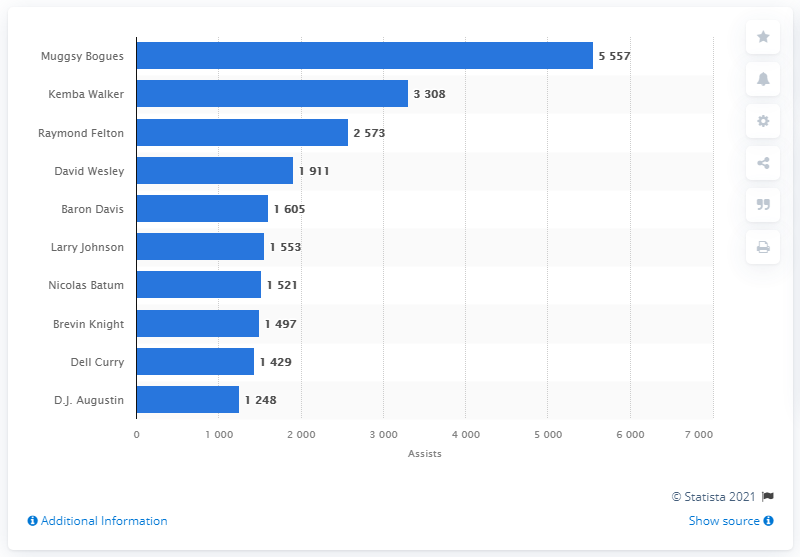Identify some key points in this picture. The current leader in career assists for the Charlotte Hornets is Muggsy Bogues. 